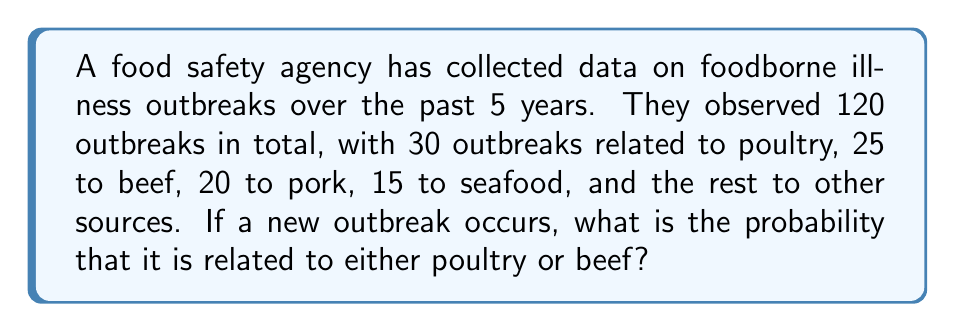Can you solve this math problem? To solve this problem, we'll follow these steps:

1. Calculate the total number of outbreaks:
   Total outbreaks = 120

2. Calculate the number of outbreaks related to poultry and beef:
   Poultry outbreaks = 30
   Beef outbreaks = 25
   Poultry and beef outbreaks combined = 30 + 25 = 55

3. Calculate the probability using the formula:
   $$P(\text{poultry or beef}) = \frac{\text{Number of favorable outcomes}}{\text{Total number of possible outcomes}}$$

   $$P(\text{poultry or beef}) = \frac{\text{Poultry and beef outbreaks}}{\text{Total outbreaks}}$$

   $$P(\text{poultry or beef}) = \frac{55}{120}$$

4. Simplify the fraction:
   $$P(\text{poultry or beef}) = \frac{11}{24} \approx 0.4583$$

5. Convert to a percentage:
   $$P(\text{poultry or beef}) \approx 45.83\%$$

Therefore, the probability that a new outbreak is related to either poultry or beef is approximately 45.83% or $\frac{11}{24}$.
Answer: $\frac{11}{24}$ or approximately 45.83% 